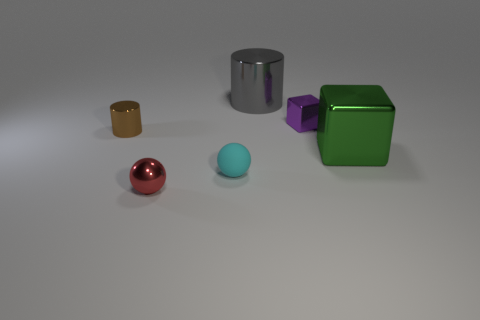Add 2 large gray shiny objects. How many objects exist? 8 Subtract all big metallic cylinders. Subtract all small rubber spheres. How many objects are left? 4 Add 1 cyan balls. How many cyan balls are left? 2 Add 4 brown cylinders. How many brown cylinders exist? 5 Subtract 0 blue balls. How many objects are left? 6 